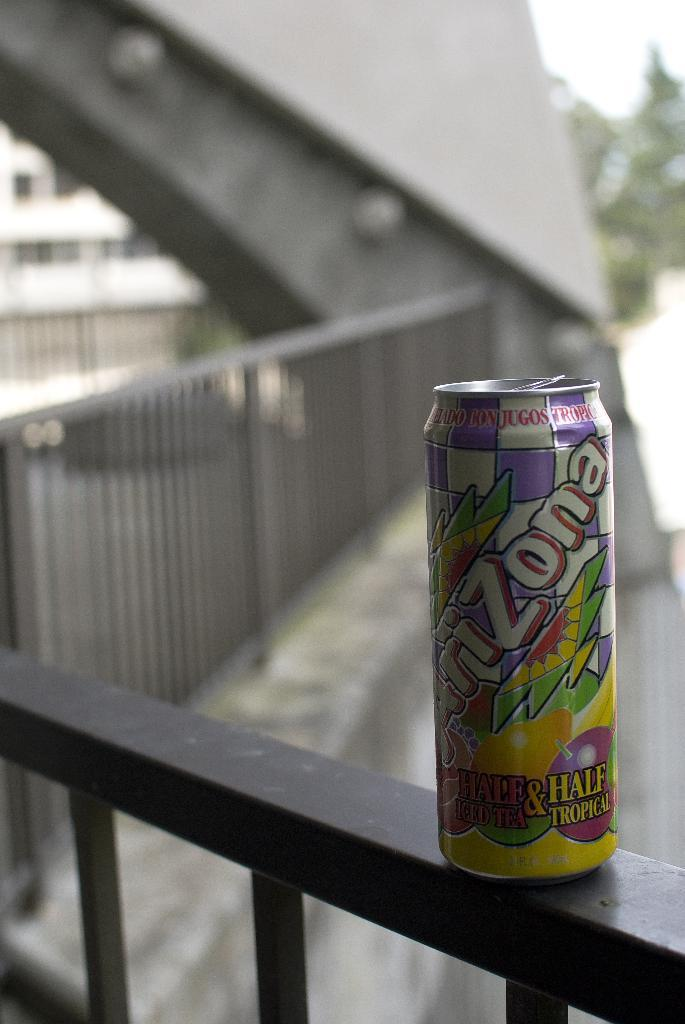What object is on the platform in the image? There is a tin on the platform. How would you describe the background of the image? The background is blurry. What can be seen in the background of the image? There is a fence visible in the background. What type of test is being conducted in the image? There is no test being conducted in the image; it only shows a tin on a platform with a blurry background and a visible fence. 